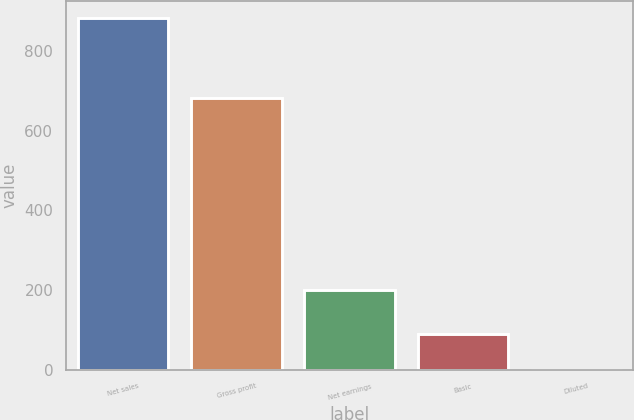Convert chart. <chart><loc_0><loc_0><loc_500><loc_500><bar_chart><fcel>Net sales<fcel>Gross profit<fcel>Net earnings<fcel>Basic<fcel>Diluted<nl><fcel>881.6<fcel>681.6<fcel>200.9<fcel>88.89<fcel>0.81<nl></chart> 